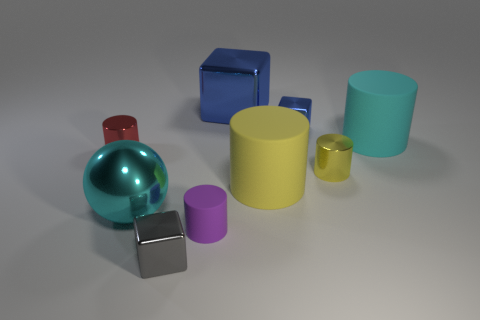There is a tiny cylinder to the left of the cyan ball; does it have the same color as the big metallic thing in front of the big yellow rubber cylinder?
Offer a very short reply. No. What is the material of the small thing left of the cyan ball that is to the left of the small rubber object?
Offer a terse response. Metal. What is the color of the rubber cylinder that is the same size as the red thing?
Provide a short and direct response. Purple. Does the cyan rubber thing have the same shape as the large shiny object in front of the large cyan matte object?
Offer a terse response. No. What is the shape of the thing that is the same color as the shiny ball?
Your answer should be very brief. Cylinder. There is a large cyan thing that is to the left of the matte cylinder to the left of the large blue metal cube; what number of rubber objects are behind it?
Keep it short and to the point. 2. There is a cube that is to the left of the large metal object that is behind the cyan ball; what is its size?
Your response must be concise. Small. What is the size of the yellow thing that is made of the same material as the tiny gray cube?
Your response must be concise. Small. What is the shape of the big thing that is both behind the tiny yellow cylinder and right of the big blue cube?
Ensure brevity in your answer.  Cylinder. Are there the same number of cubes in front of the small gray metal block and small gray matte things?
Provide a succinct answer. Yes. 